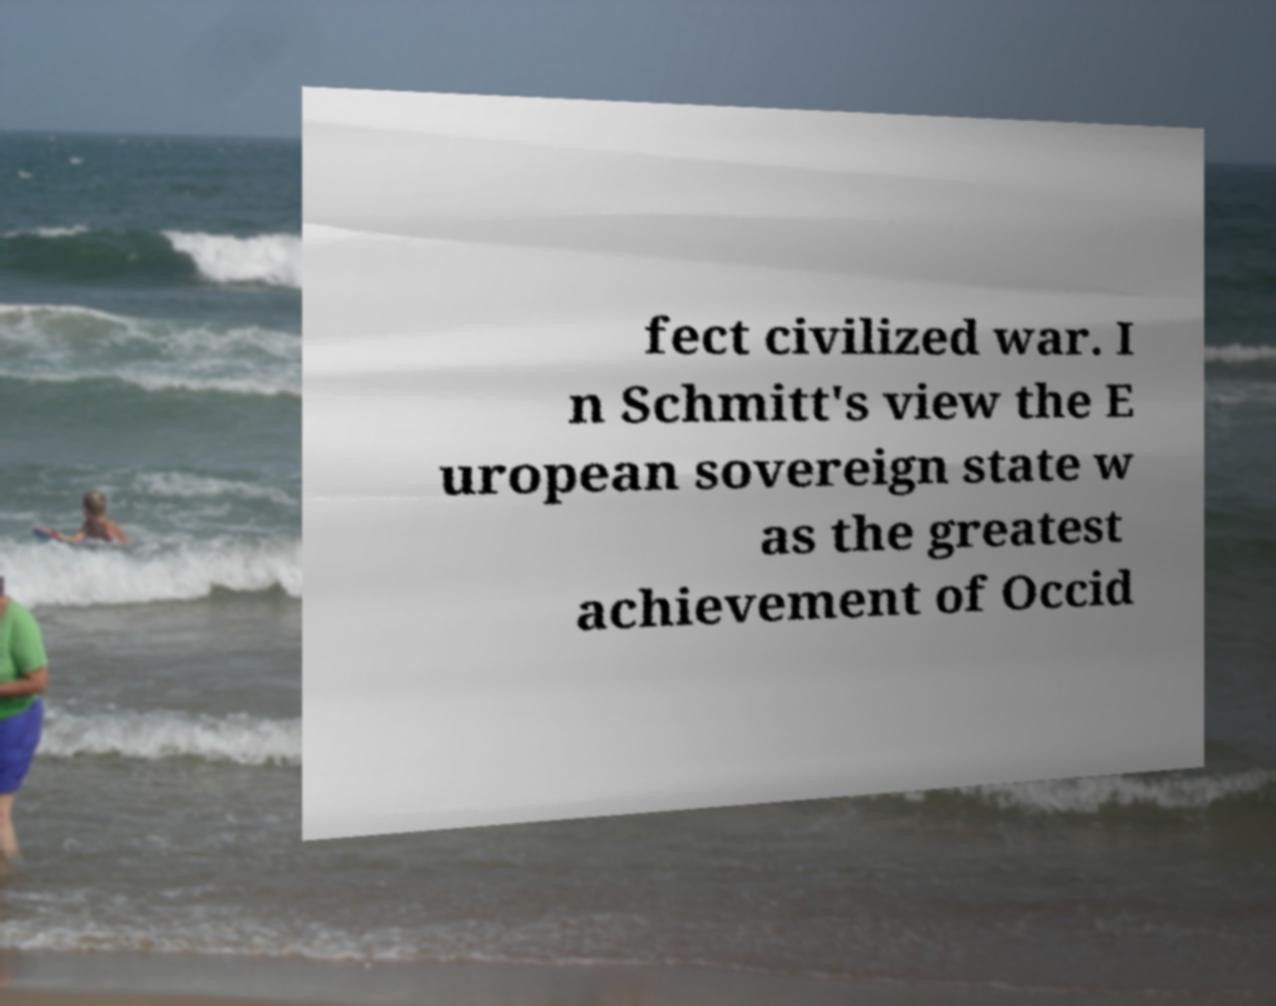There's text embedded in this image that I need extracted. Can you transcribe it verbatim? fect civilized war. I n Schmitt's view the E uropean sovereign state w as the greatest achievement of Occid 